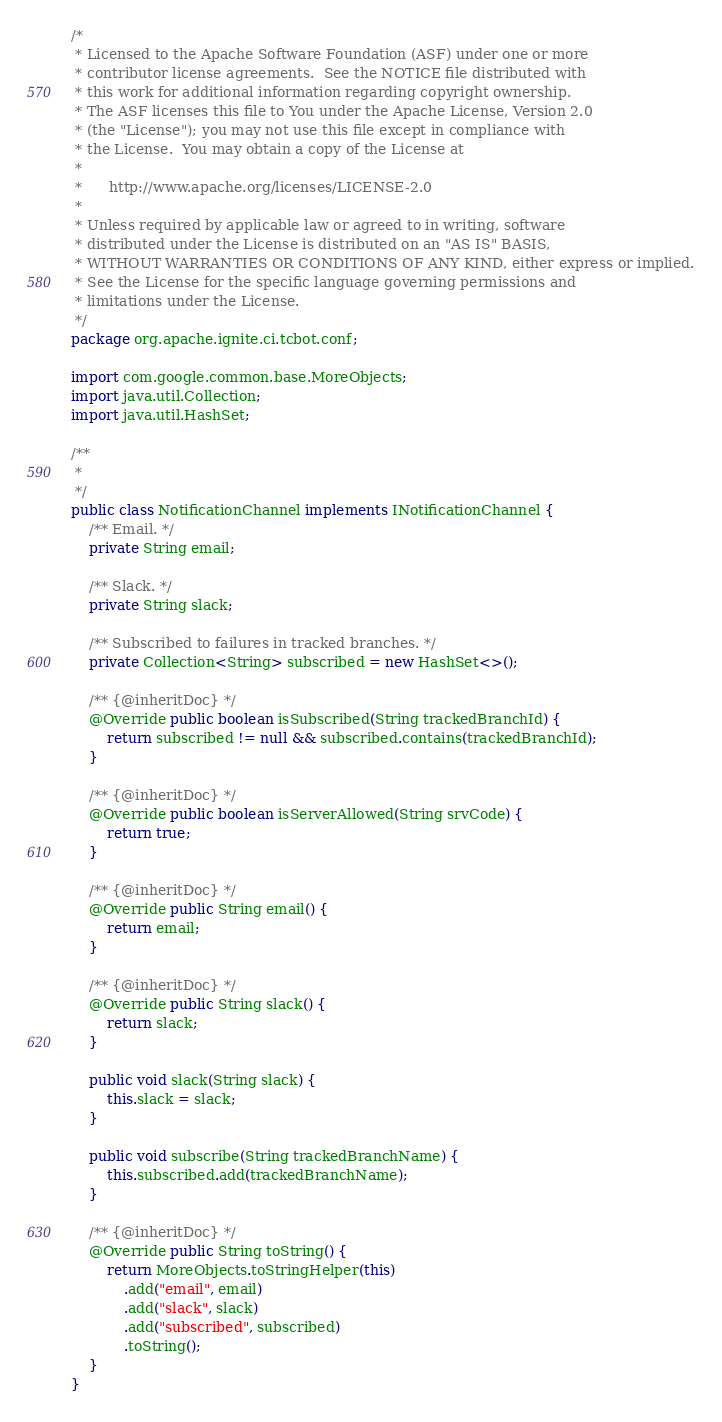Convert code to text. <code><loc_0><loc_0><loc_500><loc_500><_Java_>/*
 * Licensed to the Apache Software Foundation (ASF) under one or more
 * contributor license agreements.  See the NOTICE file distributed with
 * this work for additional information regarding copyright ownership.
 * The ASF licenses this file to You under the Apache License, Version 2.0
 * (the "License"); you may not use this file except in compliance with
 * the License.  You may obtain a copy of the License at
 *
 *      http://www.apache.org/licenses/LICENSE-2.0
 *
 * Unless required by applicable law or agreed to in writing, software
 * distributed under the License is distributed on an "AS IS" BASIS,
 * WITHOUT WARRANTIES OR CONDITIONS OF ANY KIND, either express or implied.
 * See the License for the specific language governing permissions and
 * limitations under the License.
 */
package org.apache.ignite.ci.tcbot.conf;

import com.google.common.base.MoreObjects;
import java.util.Collection;
import java.util.HashSet;

/**
 *
 */
public class NotificationChannel implements INotificationChannel {
    /** Email. */
    private String email;

    /** Slack. */
    private String slack;

    /** Subscribed to failures in tracked branches. */
    private Collection<String> subscribed = new HashSet<>();

    /** {@inheritDoc} */
    @Override public boolean isSubscribed(String trackedBranchId) {
        return subscribed != null && subscribed.contains(trackedBranchId);
    }

    /** {@inheritDoc} */
    @Override public boolean isServerAllowed(String srvCode) {
        return true;
    }

    /** {@inheritDoc} */
    @Override public String email() {
        return email;
    }

    /** {@inheritDoc} */
    @Override public String slack() {
        return slack;
    }

    public void slack(String slack) {
        this.slack = slack;
    }

    public void subscribe(String trackedBranchName) {
        this.subscribed.add(trackedBranchName);
    }

    /** {@inheritDoc} */
    @Override public String toString() {
        return MoreObjects.toStringHelper(this)
            .add("email", email)
            .add("slack", slack)
            .add("subscribed", subscribed)
            .toString();
    }
}
</code> 